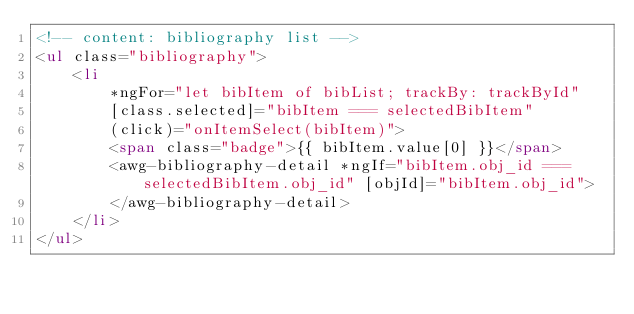Convert code to text. <code><loc_0><loc_0><loc_500><loc_500><_HTML_><!-- content: bibliography list -->
<ul class="bibliography">
    <li
        *ngFor="let bibItem of bibList; trackBy: trackById"
        [class.selected]="bibItem === selectedBibItem"
        (click)="onItemSelect(bibItem)">
        <span class="badge">{{ bibItem.value[0] }}</span>
        <awg-bibliography-detail *ngIf="bibItem.obj_id === selectedBibItem.obj_id" [objId]="bibItem.obj_id">
        </awg-bibliography-detail>
    </li>
</ul>
</code> 